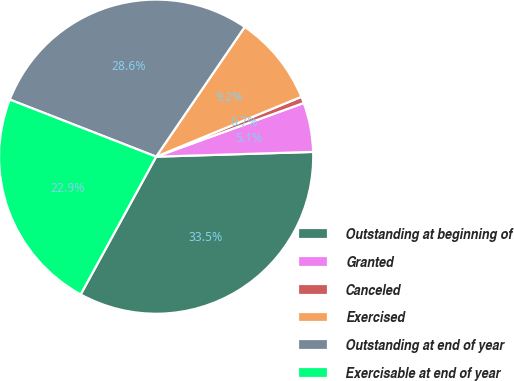<chart> <loc_0><loc_0><loc_500><loc_500><pie_chart><fcel>Outstanding at beginning of<fcel>Granted<fcel>Canceled<fcel>Exercised<fcel>Outstanding at end of year<fcel>Exercisable at end of year<nl><fcel>33.45%<fcel>5.07%<fcel>0.67%<fcel>9.24%<fcel>28.61%<fcel>22.94%<nl></chart> 